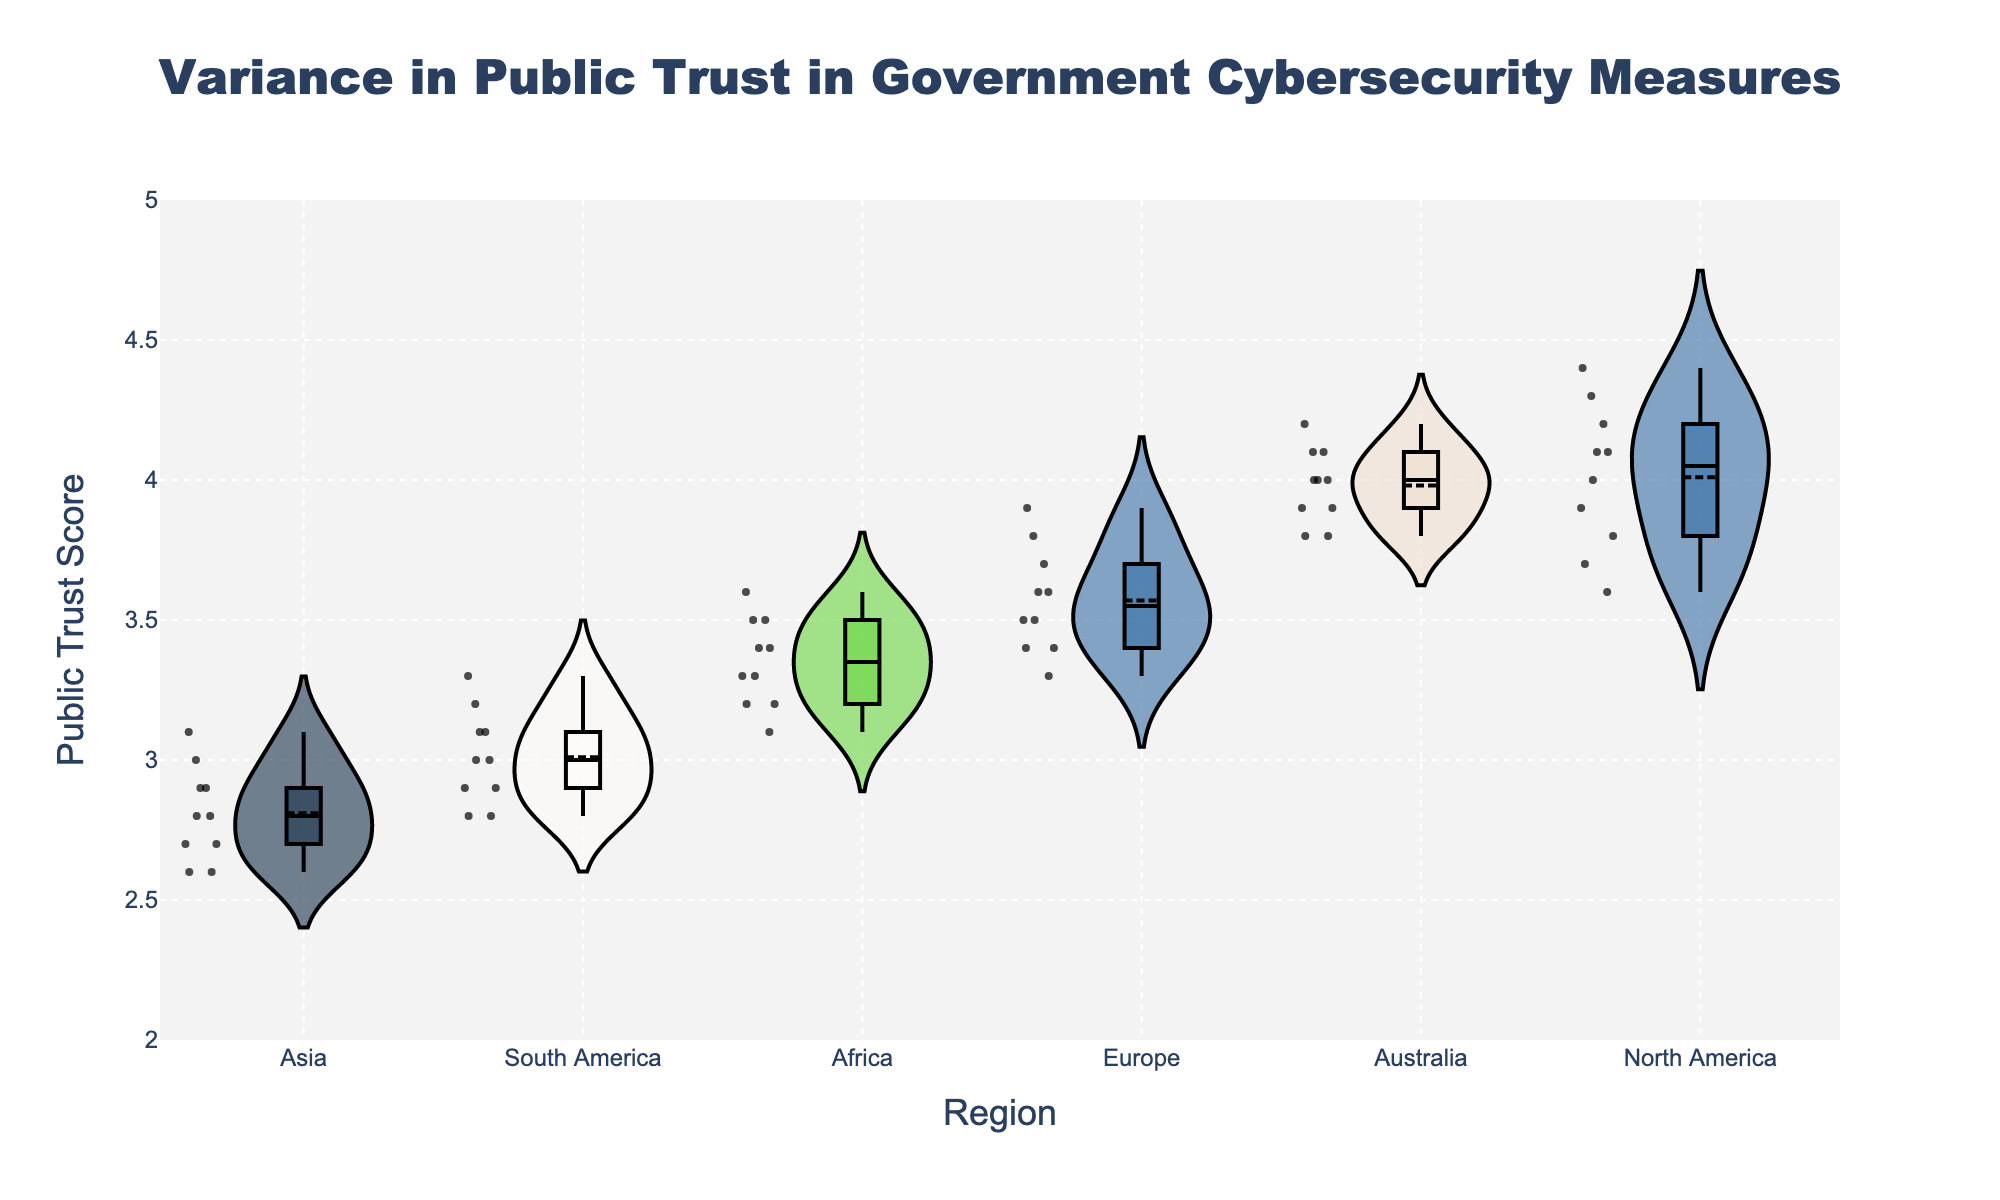What regions are represented in the plot? The x-axis of the plot lists the different regions represented. These regions are North America, Europe, Asia, Africa, South America, and Australia.
Answer: North America, Europe, Asia, Africa, South America, Australia What is the range of public trust scores shown on the y-axis? The y-axis has a range of public trust scores from 2 to 5, as indicated by the numerical ticks along the axis.
Answer: 2 to 5 Which region has the highest median public trust score? To find the region with the highest median score, look at the box plot overlay within each violin plot. The median is indicated by the line within the box. North America shows the highest median line close to 4.0.
Answer: North America Which region has the lowest median public trust score? Following the same method, check the box plot median lines. Asia has the lowest median line, which is slightly below 3.0.
Answer: Asia How does the distribution of public trust scores in Asia compare to that in Europe? The violin plot for Asia shows a narrower distribution with most scores clustering around the lower end (around 2.7 to 3.0), while Europe's distribution is more spread out within the range of roughly 3.3 to 3.9. This indicates less variation in Asia compared to Europe.
Answer: Asia has less variation, Europe is more spread out Which region shows the greatest variance in public trust scores? The region with the widest violin plot, indicating a larger distribution of values, signifies the greatest variance. North America’s violin plot is the widest, spanning from about 3.6 to 4.4.
Answer: North America What's the average public trust score for Australia based on the distribution shown? Visually estimate the average by looking at the center of Australia’s violin plot. The box plot's mean line is close to 4.0, which represents the average public trust score for Australia.
Answer: 4.0 How do the distributions of public trust scores for Africa and South America differ? Africa's distribution is centered around a higher range (3.1 to 3.6) whereas South America's distribution is slightly lower (2.8 to 3.3). This is indicated by the respective widths and shapes of the violin plots for these regions.
Answer: Africa's distribution is higher, South America's is lower Which region shows the smallest interquartile range (IQR) for public trust scores? The IQR is represented by the height of the box in the box plot overlay. Africa's box is the shortest, indicating a smaller range between its first and third quartiles.
Answer: Africa 